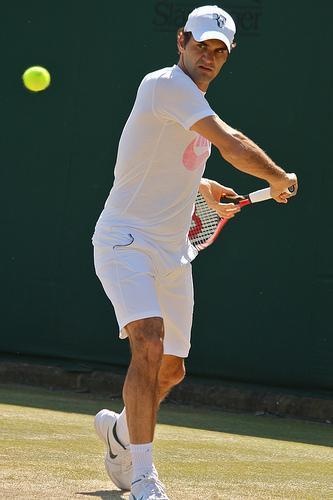How many tennis players are pictured?
Give a very brief answer. 1. 